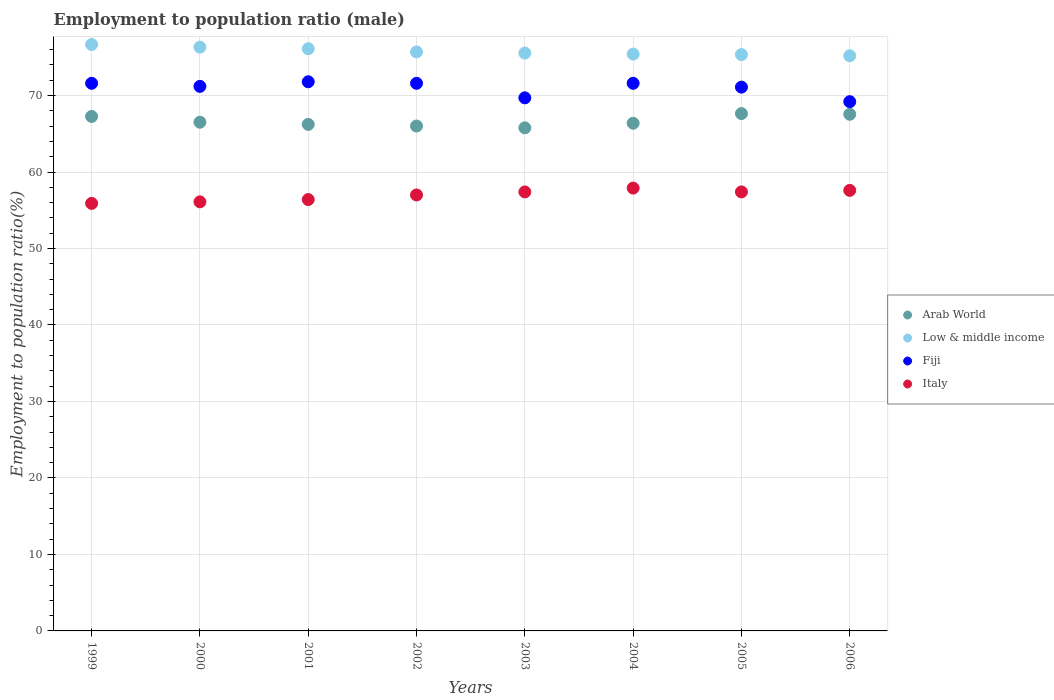How many different coloured dotlines are there?
Offer a very short reply. 4. What is the employment to population ratio in Italy in 2005?
Your answer should be very brief. 57.4. Across all years, what is the maximum employment to population ratio in Italy?
Your response must be concise. 57.9. Across all years, what is the minimum employment to population ratio in Italy?
Give a very brief answer. 55.9. What is the total employment to population ratio in Italy in the graph?
Offer a terse response. 455.7. What is the difference between the employment to population ratio in Fiji in 2001 and that in 2006?
Provide a short and direct response. 2.6. What is the difference between the employment to population ratio in Fiji in 2002 and the employment to population ratio in Low & middle income in 1999?
Provide a short and direct response. -5.07. What is the average employment to population ratio in Arab World per year?
Keep it short and to the point. 66.67. In the year 1999, what is the difference between the employment to population ratio in Fiji and employment to population ratio in Low & middle income?
Offer a very short reply. -5.07. What is the ratio of the employment to population ratio in Fiji in 2002 to that in 2003?
Your response must be concise. 1.03. Is the employment to population ratio in Arab World in 2002 less than that in 2006?
Keep it short and to the point. Yes. What is the difference between the highest and the second highest employment to population ratio in Arab World?
Offer a very short reply. 0.09. What is the difference between the highest and the lowest employment to population ratio in Fiji?
Your answer should be very brief. 2.6. Is it the case that in every year, the sum of the employment to population ratio in Low & middle income and employment to population ratio in Italy  is greater than the sum of employment to population ratio in Fiji and employment to population ratio in Arab World?
Offer a very short reply. No. Is it the case that in every year, the sum of the employment to population ratio in Arab World and employment to population ratio in Low & middle income  is greater than the employment to population ratio in Italy?
Make the answer very short. Yes. Is the employment to population ratio in Fiji strictly greater than the employment to population ratio in Italy over the years?
Give a very brief answer. Yes. Are the values on the major ticks of Y-axis written in scientific E-notation?
Offer a very short reply. No. Does the graph contain any zero values?
Give a very brief answer. No. Does the graph contain grids?
Ensure brevity in your answer.  Yes. Where does the legend appear in the graph?
Keep it short and to the point. Center right. How many legend labels are there?
Provide a short and direct response. 4. What is the title of the graph?
Give a very brief answer. Employment to population ratio (male). What is the label or title of the X-axis?
Make the answer very short. Years. What is the Employment to population ratio(%) of Arab World in 1999?
Offer a terse response. 67.26. What is the Employment to population ratio(%) of Low & middle income in 1999?
Provide a succinct answer. 76.67. What is the Employment to population ratio(%) in Fiji in 1999?
Make the answer very short. 71.6. What is the Employment to population ratio(%) of Italy in 1999?
Your answer should be very brief. 55.9. What is the Employment to population ratio(%) of Arab World in 2000?
Offer a terse response. 66.51. What is the Employment to population ratio(%) in Low & middle income in 2000?
Your answer should be compact. 76.33. What is the Employment to population ratio(%) in Fiji in 2000?
Ensure brevity in your answer.  71.2. What is the Employment to population ratio(%) of Italy in 2000?
Provide a short and direct response. 56.1. What is the Employment to population ratio(%) in Arab World in 2001?
Your response must be concise. 66.23. What is the Employment to population ratio(%) of Low & middle income in 2001?
Keep it short and to the point. 76.12. What is the Employment to population ratio(%) in Fiji in 2001?
Provide a succinct answer. 71.8. What is the Employment to population ratio(%) in Italy in 2001?
Make the answer very short. 56.4. What is the Employment to population ratio(%) of Arab World in 2002?
Make the answer very short. 66.02. What is the Employment to population ratio(%) in Low & middle income in 2002?
Offer a terse response. 75.7. What is the Employment to population ratio(%) of Fiji in 2002?
Offer a very short reply. 71.6. What is the Employment to population ratio(%) of Italy in 2002?
Your answer should be very brief. 57. What is the Employment to population ratio(%) of Arab World in 2003?
Ensure brevity in your answer.  65.78. What is the Employment to population ratio(%) in Low & middle income in 2003?
Offer a very short reply. 75.55. What is the Employment to population ratio(%) of Fiji in 2003?
Your answer should be very brief. 69.7. What is the Employment to population ratio(%) in Italy in 2003?
Provide a succinct answer. 57.4. What is the Employment to population ratio(%) of Arab World in 2004?
Ensure brevity in your answer.  66.38. What is the Employment to population ratio(%) of Low & middle income in 2004?
Keep it short and to the point. 75.41. What is the Employment to population ratio(%) in Fiji in 2004?
Provide a short and direct response. 71.6. What is the Employment to population ratio(%) in Italy in 2004?
Offer a very short reply. 57.9. What is the Employment to population ratio(%) in Arab World in 2005?
Your answer should be compact. 67.64. What is the Employment to population ratio(%) of Low & middle income in 2005?
Ensure brevity in your answer.  75.36. What is the Employment to population ratio(%) of Fiji in 2005?
Keep it short and to the point. 71.1. What is the Employment to population ratio(%) of Italy in 2005?
Provide a succinct answer. 57.4. What is the Employment to population ratio(%) of Arab World in 2006?
Ensure brevity in your answer.  67.55. What is the Employment to population ratio(%) in Low & middle income in 2006?
Your answer should be very brief. 75.2. What is the Employment to population ratio(%) of Fiji in 2006?
Your answer should be compact. 69.2. What is the Employment to population ratio(%) of Italy in 2006?
Your answer should be very brief. 57.6. Across all years, what is the maximum Employment to population ratio(%) of Arab World?
Offer a very short reply. 67.64. Across all years, what is the maximum Employment to population ratio(%) in Low & middle income?
Provide a succinct answer. 76.67. Across all years, what is the maximum Employment to population ratio(%) in Fiji?
Make the answer very short. 71.8. Across all years, what is the maximum Employment to population ratio(%) in Italy?
Your answer should be very brief. 57.9. Across all years, what is the minimum Employment to population ratio(%) of Arab World?
Make the answer very short. 65.78. Across all years, what is the minimum Employment to population ratio(%) of Low & middle income?
Provide a succinct answer. 75.2. Across all years, what is the minimum Employment to population ratio(%) of Fiji?
Make the answer very short. 69.2. Across all years, what is the minimum Employment to population ratio(%) in Italy?
Provide a succinct answer. 55.9. What is the total Employment to population ratio(%) in Arab World in the graph?
Ensure brevity in your answer.  533.37. What is the total Employment to population ratio(%) in Low & middle income in the graph?
Your answer should be compact. 606.34. What is the total Employment to population ratio(%) in Fiji in the graph?
Your answer should be very brief. 567.8. What is the total Employment to population ratio(%) of Italy in the graph?
Your response must be concise. 455.7. What is the difference between the Employment to population ratio(%) in Arab World in 1999 and that in 2000?
Make the answer very short. 0.75. What is the difference between the Employment to population ratio(%) of Low & middle income in 1999 and that in 2000?
Make the answer very short. 0.34. What is the difference between the Employment to population ratio(%) in Italy in 1999 and that in 2000?
Your answer should be compact. -0.2. What is the difference between the Employment to population ratio(%) in Arab World in 1999 and that in 2001?
Your answer should be very brief. 1.04. What is the difference between the Employment to population ratio(%) of Low & middle income in 1999 and that in 2001?
Keep it short and to the point. 0.55. What is the difference between the Employment to population ratio(%) of Italy in 1999 and that in 2001?
Make the answer very short. -0.5. What is the difference between the Employment to population ratio(%) in Arab World in 1999 and that in 2002?
Provide a short and direct response. 1.25. What is the difference between the Employment to population ratio(%) in Low & middle income in 1999 and that in 2002?
Provide a succinct answer. 0.97. What is the difference between the Employment to population ratio(%) of Arab World in 1999 and that in 2003?
Provide a short and direct response. 1.49. What is the difference between the Employment to population ratio(%) in Low & middle income in 1999 and that in 2003?
Make the answer very short. 1.12. What is the difference between the Employment to population ratio(%) of Italy in 1999 and that in 2003?
Offer a very short reply. -1.5. What is the difference between the Employment to population ratio(%) in Arab World in 1999 and that in 2004?
Offer a very short reply. 0.89. What is the difference between the Employment to population ratio(%) in Low & middle income in 1999 and that in 2004?
Offer a very short reply. 1.26. What is the difference between the Employment to population ratio(%) of Italy in 1999 and that in 2004?
Give a very brief answer. -2. What is the difference between the Employment to population ratio(%) of Arab World in 1999 and that in 2005?
Offer a very short reply. -0.37. What is the difference between the Employment to population ratio(%) of Low & middle income in 1999 and that in 2005?
Give a very brief answer. 1.31. What is the difference between the Employment to population ratio(%) in Fiji in 1999 and that in 2005?
Your answer should be compact. 0.5. What is the difference between the Employment to population ratio(%) of Italy in 1999 and that in 2005?
Provide a short and direct response. -1.5. What is the difference between the Employment to population ratio(%) of Arab World in 1999 and that in 2006?
Offer a very short reply. -0.29. What is the difference between the Employment to population ratio(%) in Low & middle income in 1999 and that in 2006?
Keep it short and to the point. 1.47. What is the difference between the Employment to population ratio(%) of Fiji in 1999 and that in 2006?
Provide a succinct answer. 2.4. What is the difference between the Employment to population ratio(%) of Italy in 1999 and that in 2006?
Ensure brevity in your answer.  -1.7. What is the difference between the Employment to population ratio(%) of Arab World in 2000 and that in 2001?
Offer a very short reply. 0.29. What is the difference between the Employment to population ratio(%) of Low & middle income in 2000 and that in 2001?
Provide a succinct answer. 0.21. What is the difference between the Employment to population ratio(%) in Fiji in 2000 and that in 2001?
Give a very brief answer. -0.6. What is the difference between the Employment to population ratio(%) of Italy in 2000 and that in 2001?
Provide a short and direct response. -0.3. What is the difference between the Employment to population ratio(%) in Arab World in 2000 and that in 2002?
Your response must be concise. 0.5. What is the difference between the Employment to population ratio(%) of Low & middle income in 2000 and that in 2002?
Offer a terse response. 0.63. What is the difference between the Employment to population ratio(%) of Fiji in 2000 and that in 2002?
Your answer should be compact. -0.4. What is the difference between the Employment to population ratio(%) of Italy in 2000 and that in 2002?
Provide a short and direct response. -0.9. What is the difference between the Employment to population ratio(%) in Arab World in 2000 and that in 2003?
Ensure brevity in your answer.  0.73. What is the difference between the Employment to population ratio(%) in Low & middle income in 2000 and that in 2003?
Ensure brevity in your answer.  0.78. What is the difference between the Employment to population ratio(%) in Italy in 2000 and that in 2003?
Provide a succinct answer. -1.3. What is the difference between the Employment to population ratio(%) of Arab World in 2000 and that in 2004?
Offer a terse response. 0.13. What is the difference between the Employment to population ratio(%) of Low & middle income in 2000 and that in 2004?
Provide a succinct answer. 0.91. What is the difference between the Employment to population ratio(%) of Arab World in 2000 and that in 2005?
Keep it short and to the point. -1.12. What is the difference between the Employment to population ratio(%) of Low & middle income in 2000 and that in 2005?
Ensure brevity in your answer.  0.97. What is the difference between the Employment to population ratio(%) of Fiji in 2000 and that in 2005?
Offer a very short reply. 0.1. What is the difference between the Employment to population ratio(%) of Italy in 2000 and that in 2005?
Keep it short and to the point. -1.3. What is the difference between the Employment to population ratio(%) of Arab World in 2000 and that in 2006?
Provide a succinct answer. -1.04. What is the difference between the Employment to population ratio(%) in Low & middle income in 2000 and that in 2006?
Offer a terse response. 1.12. What is the difference between the Employment to population ratio(%) of Fiji in 2000 and that in 2006?
Your answer should be very brief. 2. What is the difference between the Employment to population ratio(%) of Arab World in 2001 and that in 2002?
Provide a short and direct response. 0.21. What is the difference between the Employment to population ratio(%) of Low & middle income in 2001 and that in 2002?
Offer a terse response. 0.42. What is the difference between the Employment to population ratio(%) in Arab World in 2001 and that in 2003?
Your response must be concise. 0.45. What is the difference between the Employment to population ratio(%) of Low & middle income in 2001 and that in 2003?
Provide a succinct answer. 0.57. What is the difference between the Employment to population ratio(%) of Fiji in 2001 and that in 2003?
Your answer should be compact. 2.1. What is the difference between the Employment to population ratio(%) in Italy in 2001 and that in 2003?
Keep it short and to the point. -1. What is the difference between the Employment to population ratio(%) of Arab World in 2001 and that in 2004?
Ensure brevity in your answer.  -0.15. What is the difference between the Employment to population ratio(%) in Low & middle income in 2001 and that in 2004?
Provide a short and direct response. 0.71. What is the difference between the Employment to population ratio(%) in Fiji in 2001 and that in 2004?
Give a very brief answer. 0.2. What is the difference between the Employment to population ratio(%) of Arab World in 2001 and that in 2005?
Ensure brevity in your answer.  -1.41. What is the difference between the Employment to population ratio(%) in Low & middle income in 2001 and that in 2005?
Give a very brief answer. 0.76. What is the difference between the Employment to population ratio(%) in Fiji in 2001 and that in 2005?
Offer a terse response. 0.7. What is the difference between the Employment to population ratio(%) in Arab World in 2001 and that in 2006?
Your answer should be compact. -1.32. What is the difference between the Employment to population ratio(%) of Low & middle income in 2001 and that in 2006?
Provide a succinct answer. 0.92. What is the difference between the Employment to population ratio(%) of Arab World in 2002 and that in 2003?
Give a very brief answer. 0.24. What is the difference between the Employment to population ratio(%) of Low & middle income in 2002 and that in 2003?
Offer a terse response. 0.15. What is the difference between the Employment to population ratio(%) of Fiji in 2002 and that in 2003?
Ensure brevity in your answer.  1.9. What is the difference between the Employment to population ratio(%) in Arab World in 2002 and that in 2004?
Provide a succinct answer. -0.36. What is the difference between the Employment to population ratio(%) of Low & middle income in 2002 and that in 2004?
Give a very brief answer. 0.29. What is the difference between the Employment to population ratio(%) in Fiji in 2002 and that in 2004?
Ensure brevity in your answer.  0. What is the difference between the Employment to population ratio(%) in Arab World in 2002 and that in 2005?
Provide a succinct answer. -1.62. What is the difference between the Employment to population ratio(%) of Low & middle income in 2002 and that in 2005?
Provide a succinct answer. 0.34. What is the difference between the Employment to population ratio(%) in Fiji in 2002 and that in 2005?
Keep it short and to the point. 0.5. What is the difference between the Employment to population ratio(%) in Italy in 2002 and that in 2005?
Offer a terse response. -0.4. What is the difference between the Employment to population ratio(%) of Arab World in 2002 and that in 2006?
Ensure brevity in your answer.  -1.54. What is the difference between the Employment to population ratio(%) in Low & middle income in 2002 and that in 2006?
Your response must be concise. 0.5. What is the difference between the Employment to population ratio(%) in Arab World in 2003 and that in 2004?
Provide a short and direct response. -0.6. What is the difference between the Employment to population ratio(%) of Low & middle income in 2003 and that in 2004?
Ensure brevity in your answer.  0.13. What is the difference between the Employment to population ratio(%) in Fiji in 2003 and that in 2004?
Provide a short and direct response. -1.9. What is the difference between the Employment to population ratio(%) of Arab World in 2003 and that in 2005?
Offer a very short reply. -1.86. What is the difference between the Employment to population ratio(%) in Low & middle income in 2003 and that in 2005?
Your answer should be very brief. 0.19. What is the difference between the Employment to population ratio(%) of Fiji in 2003 and that in 2005?
Your response must be concise. -1.4. What is the difference between the Employment to population ratio(%) in Italy in 2003 and that in 2005?
Make the answer very short. 0. What is the difference between the Employment to population ratio(%) of Arab World in 2003 and that in 2006?
Offer a terse response. -1.77. What is the difference between the Employment to population ratio(%) in Low & middle income in 2003 and that in 2006?
Your answer should be compact. 0.35. What is the difference between the Employment to population ratio(%) in Arab World in 2004 and that in 2005?
Offer a terse response. -1.26. What is the difference between the Employment to population ratio(%) of Low & middle income in 2004 and that in 2005?
Ensure brevity in your answer.  0.06. What is the difference between the Employment to population ratio(%) of Arab World in 2004 and that in 2006?
Offer a terse response. -1.17. What is the difference between the Employment to population ratio(%) of Low & middle income in 2004 and that in 2006?
Ensure brevity in your answer.  0.21. What is the difference between the Employment to population ratio(%) of Italy in 2004 and that in 2006?
Keep it short and to the point. 0.3. What is the difference between the Employment to population ratio(%) of Arab World in 2005 and that in 2006?
Provide a succinct answer. 0.09. What is the difference between the Employment to population ratio(%) in Low & middle income in 2005 and that in 2006?
Your answer should be compact. 0.15. What is the difference between the Employment to population ratio(%) of Italy in 2005 and that in 2006?
Make the answer very short. -0.2. What is the difference between the Employment to population ratio(%) in Arab World in 1999 and the Employment to population ratio(%) in Low & middle income in 2000?
Give a very brief answer. -9.06. What is the difference between the Employment to population ratio(%) in Arab World in 1999 and the Employment to population ratio(%) in Fiji in 2000?
Your answer should be very brief. -3.94. What is the difference between the Employment to population ratio(%) in Arab World in 1999 and the Employment to population ratio(%) in Italy in 2000?
Make the answer very short. 11.16. What is the difference between the Employment to population ratio(%) of Low & middle income in 1999 and the Employment to population ratio(%) of Fiji in 2000?
Keep it short and to the point. 5.47. What is the difference between the Employment to population ratio(%) in Low & middle income in 1999 and the Employment to population ratio(%) in Italy in 2000?
Provide a short and direct response. 20.57. What is the difference between the Employment to population ratio(%) of Fiji in 1999 and the Employment to population ratio(%) of Italy in 2000?
Your answer should be very brief. 15.5. What is the difference between the Employment to population ratio(%) of Arab World in 1999 and the Employment to population ratio(%) of Low & middle income in 2001?
Your answer should be very brief. -8.86. What is the difference between the Employment to population ratio(%) of Arab World in 1999 and the Employment to population ratio(%) of Fiji in 2001?
Keep it short and to the point. -4.54. What is the difference between the Employment to population ratio(%) of Arab World in 1999 and the Employment to population ratio(%) of Italy in 2001?
Offer a terse response. 10.86. What is the difference between the Employment to population ratio(%) of Low & middle income in 1999 and the Employment to population ratio(%) of Fiji in 2001?
Your answer should be compact. 4.87. What is the difference between the Employment to population ratio(%) in Low & middle income in 1999 and the Employment to population ratio(%) in Italy in 2001?
Your answer should be compact. 20.27. What is the difference between the Employment to population ratio(%) of Fiji in 1999 and the Employment to population ratio(%) of Italy in 2001?
Your response must be concise. 15.2. What is the difference between the Employment to population ratio(%) of Arab World in 1999 and the Employment to population ratio(%) of Low & middle income in 2002?
Your answer should be compact. -8.44. What is the difference between the Employment to population ratio(%) of Arab World in 1999 and the Employment to population ratio(%) of Fiji in 2002?
Offer a very short reply. -4.34. What is the difference between the Employment to population ratio(%) in Arab World in 1999 and the Employment to population ratio(%) in Italy in 2002?
Give a very brief answer. 10.26. What is the difference between the Employment to population ratio(%) in Low & middle income in 1999 and the Employment to population ratio(%) in Fiji in 2002?
Your response must be concise. 5.07. What is the difference between the Employment to population ratio(%) in Low & middle income in 1999 and the Employment to population ratio(%) in Italy in 2002?
Your response must be concise. 19.67. What is the difference between the Employment to population ratio(%) in Fiji in 1999 and the Employment to population ratio(%) in Italy in 2002?
Your answer should be compact. 14.6. What is the difference between the Employment to population ratio(%) of Arab World in 1999 and the Employment to population ratio(%) of Low & middle income in 2003?
Ensure brevity in your answer.  -8.28. What is the difference between the Employment to population ratio(%) in Arab World in 1999 and the Employment to population ratio(%) in Fiji in 2003?
Ensure brevity in your answer.  -2.44. What is the difference between the Employment to population ratio(%) of Arab World in 1999 and the Employment to population ratio(%) of Italy in 2003?
Keep it short and to the point. 9.86. What is the difference between the Employment to population ratio(%) in Low & middle income in 1999 and the Employment to population ratio(%) in Fiji in 2003?
Your answer should be compact. 6.97. What is the difference between the Employment to population ratio(%) of Low & middle income in 1999 and the Employment to population ratio(%) of Italy in 2003?
Ensure brevity in your answer.  19.27. What is the difference between the Employment to population ratio(%) of Fiji in 1999 and the Employment to population ratio(%) of Italy in 2003?
Your answer should be compact. 14.2. What is the difference between the Employment to population ratio(%) of Arab World in 1999 and the Employment to population ratio(%) of Low & middle income in 2004?
Keep it short and to the point. -8.15. What is the difference between the Employment to population ratio(%) of Arab World in 1999 and the Employment to population ratio(%) of Fiji in 2004?
Offer a terse response. -4.34. What is the difference between the Employment to population ratio(%) in Arab World in 1999 and the Employment to population ratio(%) in Italy in 2004?
Offer a terse response. 9.36. What is the difference between the Employment to population ratio(%) in Low & middle income in 1999 and the Employment to population ratio(%) in Fiji in 2004?
Provide a short and direct response. 5.07. What is the difference between the Employment to population ratio(%) of Low & middle income in 1999 and the Employment to population ratio(%) of Italy in 2004?
Make the answer very short. 18.77. What is the difference between the Employment to population ratio(%) of Fiji in 1999 and the Employment to population ratio(%) of Italy in 2004?
Keep it short and to the point. 13.7. What is the difference between the Employment to population ratio(%) in Arab World in 1999 and the Employment to population ratio(%) in Low & middle income in 2005?
Give a very brief answer. -8.09. What is the difference between the Employment to population ratio(%) of Arab World in 1999 and the Employment to population ratio(%) of Fiji in 2005?
Make the answer very short. -3.84. What is the difference between the Employment to population ratio(%) of Arab World in 1999 and the Employment to population ratio(%) of Italy in 2005?
Provide a short and direct response. 9.86. What is the difference between the Employment to population ratio(%) in Low & middle income in 1999 and the Employment to population ratio(%) in Fiji in 2005?
Provide a succinct answer. 5.57. What is the difference between the Employment to population ratio(%) in Low & middle income in 1999 and the Employment to population ratio(%) in Italy in 2005?
Provide a succinct answer. 19.27. What is the difference between the Employment to population ratio(%) of Arab World in 1999 and the Employment to population ratio(%) of Low & middle income in 2006?
Offer a very short reply. -7.94. What is the difference between the Employment to population ratio(%) in Arab World in 1999 and the Employment to population ratio(%) in Fiji in 2006?
Make the answer very short. -1.94. What is the difference between the Employment to population ratio(%) in Arab World in 1999 and the Employment to population ratio(%) in Italy in 2006?
Provide a short and direct response. 9.66. What is the difference between the Employment to population ratio(%) of Low & middle income in 1999 and the Employment to population ratio(%) of Fiji in 2006?
Provide a succinct answer. 7.47. What is the difference between the Employment to population ratio(%) of Low & middle income in 1999 and the Employment to population ratio(%) of Italy in 2006?
Ensure brevity in your answer.  19.07. What is the difference between the Employment to population ratio(%) of Arab World in 2000 and the Employment to population ratio(%) of Low & middle income in 2001?
Your answer should be compact. -9.61. What is the difference between the Employment to population ratio(%) of Arab World in 2000 and the Employment to population ratio(%) of Fiji in 2001?
Your answer should be compact. -5.29. What is the difference between the Employment to population ratio(%) in Arab World in 2000 and the Employment to population ratio(%) in Italy in 2001?
Your answer should be compact. 10.11. What is the difference between the Employment to population ratio(%) of Low & middle income in 2000 and the Employment to population ratio(%) of Fiji in 2001?
Provide a short and direct response. 4.53. What is the difference between the Employment to population ratio(%) in Low & middle income in 2000 and the Employment to population ratio(%) in Italy in 2001?
Ensure brevity in your answer.  19.93. What is the difference between the Employment to population ratio(%) in Arab World in 2000 and the Employment to population ratio(%) in Low & middle income in 2002?
Keep it short and to the point. -9.19. What is the difference between the Employment to population ratio(%) of Arab World in 2000 and the Employment to population ratio(%) of Fiji in 2002?
Provide a succinct answer. -5.09. What is the difference between the Employment to population ratio(%) of Arab World in 2000 and the Employment to population ratio(%) of Italy in 2002?
Keep it short and to the point. 9.51. What is the difference between the Employment to population ratio(%) of Low & middle income in 2000 and the Employment to population ratio(%) of Fiji in 2002?
Provide a succinct answer. 4.73. What is the difference between the Employment to population ratio(%) in Low & middle income in 2000 and the Employment to population ratio(%) in Italy in 2002?
Offer a very short reply. 19.33. What is the difference between the Employment to population ratio(%) of Fiji in 2000 and the Employment to population ratio(%) of Italy in 2002?
Provide a succinct answer. 14.2. What is the difference between the Employment to population ratio(%) in Arab World in 2000 and the Employment to population ratio(%) in Low & middle income in 2003?
Your answer should be very brief. -9.03. What is the difference between the Employment to population ratio(%) in Arab World in 2000 and the Employment to population ratio(%) in Fiji in 2003?
Keep it short and to the point. -3.19. What is the difference between the Employment to population ratio(%) of Arab World in 2000 and the Employment to population ratio(%) of Italy in 2003?
Your answer should be compact. 9.11. What is the difference between the Employment to population ratio(%) in Low & middle income in 2000 and the Employment to population ratio(%) in Fiji in 2003?
Keep it short and to the point. 6.63. What is the difference between the Employment to population ratio(%) in Low & middle income in 2000 and the Employment to population ratio(%) in Italy in 2003?
Keep it short and to the point. 18.93. What is the difference between the Employment to population ratio(%) in Fiji in 2000 and the Employment to population ratio(%) in Italy in 2003?
Provide a short and direct response. 13.8. What is the difference between the Employment to population ratio(%) in Arab World in 2000 and the Employment to population ratio(%) in Low & middle income in 2004?
Offer a terse response. -8.9. What is the difference between the Employment to population ratio(%) of Arab World in 2000 and the Employment to population ratio(%) of Fiji in 2004?
Provide a short and direct response. -5.09. What is the difference between the Employment to population ratio(%) of Arab World in 2000 and the Employment to population ratio(%) of Italy in 2004?
Ensure brevity in your answer.  8.61. What is the difference between the Employment to population ratio(%) in Low & middle income in 2000 and the Employment to population ratio(%) in Fiji in 2004?
Your answer should be very brief. 4.73. What is the difference between the Employment to population ratio(%) in Low & middle income in 2000 and the Employment to population ratio(%) in Italy in 2004?
Provide a succinct answer. 18.43. What is the difference between the Employment to population ratio(%) in Fiji in 2000 and the Employment to population ratio(%) in Italy in 2004?
Provide a short and direct response. 13.3. What is the difference between the Employment to population ratio(%) in Arab World in 2000 and the Employment to population ratio(%) in Low & middle income in 2005?
Keep it short and to the point. -8.84. What is the difference between the Employment to population ratio(%) of Arab World in 2000 and the Employment to population ratio(%) of Fiji in 2005?
Give a very brief answer. -4.59. What is the difference between the Employment to population ratio(%) in Arab World in 2000 and the Employment to population ratio(%) in Italy in 2005?
Your answer should be very brief. 9.11. What is the difference between the Employment to population ratio(%) of Low & middle income in 2000 and the Employment to population ratio(%) of Fiji in 2005?
Ensure brevity in your answer.  5.23. What is the difference between the Employment to population ratio(%) in Low & middle income in 2000 and the Employment to population ratio(%) in Italy in 2005?
Give a very brief answer. 18.93. What is the difference between the Employment to population ratio(%) in Arab World in 2000 and the Employment to population ratio(%) in Low & middle income in 2006?
Provide a succinct answer. -8.69. What is the difference between the Employment to population ratio(%) of Arab World in 2000 and the Employment to population ratio(%) of Fiji in 2006?
Ensure brevity in your answer.  -2.69. What is the difference between the Employment to population ratio(%) of Arab World in 2000 and the Employment to population ratio(%) of Italy in 2006?
Ensure brevity in your answer.  8.91. What is the difference between the Employment to population ratio(%) of Low & middle income in 2000 and the Employment to population ratio(%) of Fiji in 2006?
Your response must be concise. 7.13. What is the difference between the Employment to population ratio(%) of Low & middle income in 2000 and the Employment to population ratio(%) of Italy in 2006?
Make the answer very short. 18.73. What is the difference between the Employment to population ratio(%) of Fiji in 2000 and the Employment to population ratio(%) of Italy in 2006?
Provide a succinct answer. 13.6. What is the difference between the Employment to population ratio(%) in Arab World in 2001 and the Employment to population ratio(%) in Low & middle income in 2002?
Your answer should be very brief. -9.47. What is the difference between the Employment to population ratio(%) in Arab World in 2001 and the Employment to population ratio(%) in Fiji in 2002?
Make the answer very short. -5.37. What is the difference between the Employment to population ratio(%) of Arab World in 2001 and the Employment to population ratio(%) of Italy in 2002?
Provide a succinct answer. 9.23. What is the difference between the Employment to population ratio(%) in Low & middle income in 2001 and the Employment to population ratio(%) in Fiji in 2002?
Make the answer very short. 4.52. What is the difference between the Employment to population ratio(%) in Low & middle income in 2001 and the Employment to population ratio(%) in Italy in 2002?
Your answer should be compact. 19.12. What is the difference between the Employment to population ratio(%) of Fiji in 2001 and the Employment to population ratio(%) of Italy in 2002?
Make the answer very short. 14.8. What is the difference between the Employment to population ratio(%) of Arab World in 2001 and the Employment to population ratio(%) of Low & middle income in 2003?
Offer a terse response. -9.32. What is the difference between the Employment to population ratio(%) in Arab World in 2001 and the Employment to population ratio(%) in Fiji in 2003?
Ensure brevity in your answer.  -3.47. What is the difference between the Employment to population ratio(%) in Arab World in 2001 and the Employment to population ratio(%) in Italy in 2003?
Your response must be concise. 8.83. What is the difference between the Employment to population ratio(%) in Low & middle income in 2001 and the Employment to population ratio(%) in Fiji in 2003?
Ensure brevity in your answer.  6.42. What is the difference between the Employment to population ratio(%) in Low & middle income in 2001 and the Employment to population ratio(%) in Italy in 2003?
Your response must be concise. 18.72. What is the difference between the Employment to population ratio(%) of Fiji in 2001 and the Employment to population ratio(%) of Italy in 2003?
Offer a very short reply. 14.4. What is the difference between the Employment to population ratio(%) of Arab World in 2001 and the Employment to population ratio(%) of Low & middle income in 2004?
Give a very brief answer. -9.19. What is the difference between the Employment to population ratio(%) of Arab World in 2001 and the Employment to population ratio(%) of Fiji in 2004?
Keep it short and to the point. -5.37. What is the difference between the Employment to population ratio(%) of Arab World in 2001 and the Employment to population ratio(%) of Italy in 2004?
Provide a succinct answer. 8.33. What is the difference between the Employment to population ratio(%) of Low & middle income in 2001 and the Employment to population ratio(%) of Fiji in 2004?
Keep it short and to the point. 4.52. What is the difference between the Employment to population ratio(%) in Low & middle income in 2001 and the Employment to population ratio(%) in Italy in 2004?
Your answer should be very brief. 18.22. What is the difference between the Employment to population ratio(%) in Arab World in 2001 and the Employment to population ratio(%) in Low & middle income in 2005?
Your answer should be very brief. -9.13. What is the difference between the Employment to population ratio(%) of Arab World in 2001 and the Employment to population ratio(%) of Fiji in 2005?
Your answer should be compact. -4.87. What is the difference between the Employment to population ratio(%) of Arab World in 2001 and the Employment to population ratio(%) of Italy in 2005?
Keep it short and to the point. 8.83. What is the difference between the Employment to population ratio(%) in Low & middle income in 2001 and the Employment to population ratio(%) in Fiji in 2005?
Your answer should be compact. 5.02. What is the difference between the Employment to population ratio(%) of Low & middle income in 2001 and the Employment to population ratio(%) of Italy in 2005?
Your answer should be compact. 18.72. What is the difference between the Employment to population ratio(%) of Fiji in 2001 and the Employment to population ratio(%) of Italy in 2005?
Your answer should be very brief. 14.4. What is the difference between the Employment to population ratio(%) of Arab World in 2001 and the Employment to population ratio(%) of Low & middle income in 2006?
Give a very brief answer. -8.97. What is the difference between the Employment to population ratio(%) of Arab World in 2001 and the Employment to population ratio(%) of Fiji in 2006?
Your answer should be very brief. -2.97. What is the difference between the Employment to population ratio(%) in Arab World in 2001 and the Employment to population ratio(%) in Italy in 2006?
Provide a succinct answer. 8.63. What is the difference between the Employment to population ratio(%) of Low & middle income in 2001 and the Employment to population ratio(%) of Fiji in 2006?
Your response must be concise. 6.92. What is the difference between the Employment to population ratio(%) in Low & middle income in 2001 and the Employment to population ratio(%) in Italy in 2006?
Provide a succinct answer. 18.52. What is the difference between the Employment to population ratio(%) in Fiji in 2001 and the Employment to population ratio(%) in Italy in 2006?
Provide a short and direct response. 14.2. What is the difference between the Employment to population ratio(%) in Arab World in 2002 and the Employment to population ratio(%) in Low & middle income in 2003?
Your response must be concise. -9.53. What is the difference between the Employment to population ratio(%) of Arab World in 2002 and the Employment to population ratio(%) of Fiji in 2003?
Offer a very short reply. -3.69. What is the difference between the Employment to population ratio(%) in Arab World in 2002 and the Employment to population ratio(%) in Italy in 2003?
Your response must be concise. 8.62. What is the difference between the Employment to population ratio(%) of Low & middle income in 2002 and the Employment to population ratio(%) of Fiji in 2003?
Make the answer very short. 6. What is the difference between the Employment to population ratio(%) of Low & middle income in 2002 and the Employment to population ratio(%) of Italy in 2003?
Your answer should be very brief. 18.3. What is the difference between the Employment to population ratio(%) in Arab World in 2002 and the Employment to population ratio(%) in Low & middle income in 2004?
Offer a terse response. -9.4. What is the difference between the Employment to population ratio(%) of Arab World in 2002 and the Employment to population ratio(%) of Fiji in 2004?
Make the answer very short. -5.58. What is the difference between the Employment to population ratio(%) in Arab World in 2002 and the Employment to population ratio(%) in Italy in 2004?
Offer a terse response. 8.12. What is the difference between the Employment to population ratio(%) of Low & middle income in 2002 and the Employment to population ratio(%) of Fiji in 2004?
Offer a terse response. 4.1. What is the difference between the Employment to population ratio(%) in Low & middle income in 2002 and the Employment to population ratio(%) in Italy in 2004?
Offer a very short reply. 17.8. What is the difference between the Employment to population ratio(%) in Fiji in 2002 and the Employment to population ratio(%) in Italy in 2004?
Your answer should be very brief. 13.7. What is the difference between the Employment to population ratio(%) of Arab World in 2002 and the Employment to population ratio(%) of Low & middle income in 2005?
Ensure brevity in your answer.  -9.34. What is the difference between the Employment to population ratio(%) in Arab World in 2002 and the Employment to population ratio(%) in Fiji in 2005?
Ensure brevity in your answer.  -5.08. What is the difference between the Employment to population ratio(%) in Arab World in 2002 and the Employment to population ratio(%) in Italy in 2005?
Offer a terse response. 8.62. What is the difference between the Employment to population ratio(%) of Low & middle income in 2002 and the Employment to population ratio(%) of Fiji in 2005?
Give a very brief answer. 4.6. What is the difference between the Employment to population ratio(%) in Low & middle income in 2002 and the Employment to population ratio(%) in Italy in 2005?
Ensure brevity in your answer.  18.3. What is the difference between the Employment to population ratio(%) of Arab World in 2002 and the Employment to population ratio(%) of Low & middle income in 2006?
Offer a very short reply. -9.19. What is the difference between the Employment to population ratio(%) of Arab World in 2002 and the Employment to population ratio(%) of Fiji in 2006?
Your answer should be compact. -3.19. What is the difference between the Employment to population ratio(%) in Arab World in 2002 and the Employment to population ratio(%) in Italy in 2006?
Offer a very short reply. 8.41. What is the difference between the Employment to population ratio(%) in Low & middle income in 2002 and the Employment to population ratio(%) in Fiji in 2006?
Your response must be concise. 6.5. What is the difference between the Employment to population ratio(%) of Low & middle income in 2002 and the Employment to population ratio(%) of Italy in 2006?
Offer a very short reply. 18.1. What is the difference between the Employment to population ratio(%) in Fiji in 2002 and the Employment to population ratio(%) in Italy in 2006?
Make the answer very short. 14. What is the difference between the Employment to population ratio(%) in Arab World in 2003 and the Employment to population ratio(%) in Low & middle income in 2004?
Keep it short and to the point. -9.63. What is the difference between the Employment to population ratio(%) of Arab World in 2003 and the Employment to population ratio(%) of Fiji in 2004?
Your response must be concise. -5.82. What is the difference between the Employment to population ratio(%) in Arab World in 2003 and the Employment to population ratio(%) in Italy in 2004?
Keep it short and to the point. 7.88. What is the difference between the Employment to population ratio(%) in Low & middle income in 2003 and the Employment to population ratio(%) in Fiji in 2004?
Provide a short and direct response. 3.95. What is the difference between the Employment to population ratio(%) in Low & middle income in 2003 and the Employment to population ratio(%) in Italy in 2004?
Keep it short and to the point. 17.65. What is the difference between the Employment to population ratio(%) in Fiji in 2003 and the Employment to population ratio(%) in Italy in 2004?
Offer a terse response. 11.8. What is the difference between the Employment to population ratio(%) in Arab World in 2003 and the Employment to population ratio(%) in Low & middle income in 2005?
Your response must be concise. -9.58. What is the difference between the Employment to population ratio(%) of Arab World in 2003 and the Employment to population ratio(%) of Fiji in 2005?
Give a very brief answer. -5.32. What is the difference between the Employment to population ratio(%) in Arab World in 2003 and the Employment to population ratio(%) in Italy in 2005?
Provide a short and direct response. 8.38. What is the difference between the Employment to population ratio(%) of Low & middle income in 2003 and the Employment to population ratio(%) of Fiji in 2005?
Provide a short and direct response. 4.45. What is the difference between the Employment to population ratio(%) of Low & middle income in 2003 and the Employment to population ratio(%) of Italy in 2005?
Offer a terse response. 18.15. What is the difference between the Employment to population ratio(%) of Fiji in 2003 and the Employment to population ratio(%) of Italy in 2005?
Keep it short and to the point. 12.3. What is the difference between the Employment to population ratio(%) of Arab World in 2003 and the Employment to population ratio(%) of Low & middle income in 2006?
Provide a succinct answer. -9.42. What is the difference between the Employment to population ratio(%) of Arab World in 2003 and the Employment to population ratio(%) of Fiji in 2006?
Your answer should be very brief. -3.42. What is the difference between the Employment to population ratio(%) of Arab World in 2003 and the Employment to population ratio(%) of Italy in 2006?
Give a very brief answer. 8.18. What is the difference between the Employment to population ratio(%) in Low & middle income in 2003 and the Employment to population ratio(%) in Fiji in 2006?
Keep it short and to the point. 6.35. What is the difference between the Employment to population ratio(%) in Low & middle income in 2003 and the Employment to population ratio(%) in Italy in 2006?
Keep it short and to the point. 17.95. What is the difference between the Employment to population ratio(%) of Fiji in 2003 and the Employment to population ratio(%) of Italy in 2006?
Give a very brief answer. 12.1. What is the difference between the Employment to population ratio(%) in Arab World in 2004 and the Employment to population ratio(%) in Low & middle income in 2005?
Your answer should be compact. -8.98. What is the difference between the Employment to population ratio(%) in Arab World in 2004 and the Employment to population ratio(%) in Fiji in 2005?
Give a very brief answer. -4.72. What is the difference between the Employment to population ratio(%) in Arab World in 2004 and the Employment to population ratio(%) in Italy in 2005?
Offer a terse response. 8.98. What is the difference between the Employment to population ratio(%) of Low & middle income in 2004 and the Employment to population ratio(%) of Fiji in 2005?
Ensure brevity in your answer.  4.32. What is the difference between the Employment to population ratio(%) of Low & middle income in 2004 and the Employment to population ratio(%) of Italy in 2005?
Your answer should be compact. 18.02. What is the difference between the Employment to population ratio(%) in Arab World in 2004 and the Employment to population ratio(%) in Low & middle income in 2006?
Give a very brief answer. -8.82. What is the difference between the Employment to population ratio(%) of Arab World in 2004 and the Employment to population ratio(%) of Fiji in 2006?
Give a very brief answer. -2.82. What is the difference between the Employment to population ratio(%) of Arab World in 2004 and the Employment to population ratio(%) of Italy in 2006?
Give a very brief answer. 8.78. What is the difference between the Employment to population ratio(%) in Low & middle income in 2004 and the Employment to population ratio(%) in Fiji in 2006?
Offer a very short reply. 6.21. What is the difference between the Employment to population ratio(%) in Low & middle income in 2004 and the Employment to population ratio(%) in Italy in 2006?
Give a very brief answer. 17.82. What is the difference between the Employment to population ratio(%) in Arab World in 2005 and the Employment to population ratio(%) in Low & middle income in 2006?
Your answer should be very brief. -7.56. What is the difference between the Employment to population ratio(%) of Arab World in 2005 and the Employment to population ratio(%) of Fiji in 2006?
Your answer should be very brief. -1.56. What is the difference between the Employment to population ratio(%) of Arab World in 2005 and the Employment to population ratio(%) of Italy in 2006?
Offer a terse response. 10.04. What is the difference between the Employment to population ratio(%) of Low & middle income in 2005 and the Employment to population ratio(%) of Fiji in 2006?
Provide a short and direct response. 6.16. What is the difference between the Employment to population ratio(%) in Low & middle income in 2005 and the Employment to population ratio(%) in Italy in 2006?
Offer a very short reply. 17.76. What is the average Employment to population ratio(%) of Arab World per year?
Keep it short and to the point. 66.67. What is the average Employment to population ratio(%) of Low & middle income per year?
Offer a terse response. 75.79. What is the average Employment to population ratio(%) of Fiji per year?
Your answer should be very brief. 70.97. What is the average Employment to population ratio(%) in Italy per year?
Give a very brief answer. 56.96. In the year 1999, what is the difference between the Employment to population ratio(%) of Arab World and Employment to population ratio(%) of Low & middle income?
Provide a succinct answer. -9.41. In the year 1999, what is the difference between the Employment to population ratio(%) in Arab World and Employment to population ratio(%) in Fiji?
Provide a succinct answer. -4.34. In the year 1999, what is the difference between the Employment to population ratio(%) in Arab World and Employment to population ratio(%) in Italy?
Your answer should be compact. 11.36. In the year 1999, what is the difference between the Employment to population ratio(%) of Low & middle income and Employment to population ratio(%) of Fiji?
Give a very brief answer. 5.07. In the year 1999, what is the difference between the Employment to population ratio(%) in Low & middle income and Employment to population ratio(%) in Italy?
Your response must be concise. 20.77. In the year 2000, what is the difference between the Employment to population ratio(%) of Arab World and Employment to population ratio(%) of Low & middle income?
Your answer should be very brief. -9.81. In the year 2000, what is the difference between the Employment to population ratio(%) in Arab World and Employment to population ratio(%) in Fiji?
Your answer should be compact. -4.69. In the year 2000, what is the difference between the Employment to population ratio(%) in Arab World and Employment to population ratio(%) in Italy?
Offer a very short reply. 10.41. In the year 2000, what is the difference between the Employment to population ratio(%) in Low & middle income and Employment to population ratio(%) in Fiji?
Your answer should be very brief. 5.13. In the year 2000, what is the difference between the Employment to population ratio(%) of Low & middle income and Employment to population ratio(%) of Italy?
Offer a very short reply. 20.23. In the year 2000, what is the difference between the Employment to population ratio(%) in Fiji and Employment to population ratio(%) in Italy?
Your response must be concise. 15.1. In the year 2001, what is the difference between the Employment to population ratio(%) in Arab World and Employment to population ratio(%) in Low & middle income?
Your answer should be very brief. -9.89. In the year 2001, what is the difference between the Employment to population ratio(%) in Arab World and Employment to population ratio(%) in Fiji?
Your answer should be very brief. -5.57. In the year 2001, what is the difference between the Employment to population ratio(%) in Arab World and Employment to population ratio(%) in Italy?
Ensure brevity in your answer.  9.83. In the year 2001, what is the difference between the Employment to population ratio(%) of Low & middle income and Employment to population ratio(%) of Fiji?
Make the answer very short. 4.32. In the year 2001, what is the difference between the Employment to population ratio(%) in Low & middle income and Employment to population ratio(%) in Italy?
Your answer should be compact. 19.72. In the year 2002, what is the difference between the Employment to population ratio(%) in Arab World and Employment to population ratio(%) in Low & middle income?
Offer a very short reply. -9.69. In the year 2002, what is the difference between the Employment to population ratio(%) in Arab World and Employment to population ratio(%) in Fiji?
Provide a succinct answer. -5.58. In the year 2002, what is the difference between the Employment to population ratio(%) of Arab World and Employment to population ratio(%) of Italy?
Give a very brief answer. 9.02. In the year 2002, what is the difference between the Employment to population ratio(%) of Low & middle income and Employment to population ratio(%) of Fiji?
Offer a terse response. 4.1. In the year 2002, what is the difference between the Employment to population ratio(%) in Low & middle income and Employment to population ratio(%) in Italy?
Your response must be concise. 18.7. In the year 2003, what is the difference between the Employment to population ratio(%) in Arab World and Employment to population ratio(%) in Low & middle income?
Make the answer very short. -9.77. In the year 2003, what is the difference between the Employment to population ratio(%) in Arab World and Employment to population ratio(%) in Fiji?
Your response must be concise. -3.92. In the year 2003, what is the difference between the Employment to population ratio(%) of Arab World and Employment to population ratio(%) of Italy?
Give a very brief answer. 8.38. In the year 2003, what is the difference between the Employment to population ratio(%) of Low & middle income and Employment to population ratio(%) of Fiji?
Ensure brevity in your answer.  5.85. In the year 2003, what is the difference between the Employment to population ratio(%) of Low & middle income and Employment to population ratio(%) of Italy?
Your answer should be compact. 18.15. In the year 2003, what is the difference between the Employment to population ratio(%) in Fiji and Employment to population ratio(%) in Italy?
Keep it short and to the point. 12.3. In the year 2004, what is the difference between the Employment to population ratio(%) of Arab World and Employment to population ratio(%) of Low & middle income?
Your answer should be very brief. -9.04. In the year 2004, what is the difference between the Employment to population ratio(%) of Arab World and Employment to population ratio(%) of Fiji?
Make the answer very short. -5.22. In the year 2004, what is the difference between the Employment to population ratio(%) of Arab World and Employment to population ratio(%) of Italy?
Provide a succinct answer. 8.48. In the year 2004, what is the difference between the Employment to population ratio(%) of Low & middle income and Employment to population ratio(%) of Fiji?
Ensure brevity in your answer.  3.81. In the year 2004, what is the difference between the Employment to population ratio(%) in Low & middle income and Employment to population ratio(%) in Italy?
Give a very brief answer. 17.52. In the year 2005, what is the difference between the Employment to population ratio(%) in Arab World and Employment to population ratio(%) in Low & middle income?
Provide a succinct answer. -7.72. In the year 2005, what is the difference between the Employment to population ratio(%) in Arab World and Employment to population ratio(%) in Fiji?
Your answer should be very brief. -3.46. In the year 2005, what is the difference between the Employment to population ratio(%) in Arab World and Employment to population ratio(%) in Italy?
Offer a terse response. 10.24. In the year 2005, what is the difference between the Employment to population ratio(%) of Low & middle income and Employment to population ratio(%) of Fiji?
Your answer should be compact. 4.26. In the year 2005, what is the difference between the Employment to population ratio(%) in Low & middle income and Employment to population ratio(%) in Italy?
Offer a terse response. 17.96. In the year 2005, what is the difference between the Employment to population ratio(%) in Fiji and Employment to population ratio(%) in Italy?
Provide a short and direct response. 13.7. In the year 2006, what is the difference between the Employment to population ratio(%) in Arab World and Employment to population ratio(%) in Low & middle income?
Your answer should be compact. -7.65. In the year 2006, what is the difference between the Employment to population ratio(%) in Arab World and Employment to population ratio(%) in Fiji?
Provide a short and direct response. -1.65. In the year 2006, what is the difference between the Employment to population ratio(%) in Arab World and Employment to population ratio(%) in Italy?
Your answer should be compact. 9.95. In the year 2006, what is the difference between the Employment to population ratio(%) in Low & middle income and Employment to population ratio(%) in Fiji?
Offer a very short reply. 6. In the year 2006, what is the difference between the Employment to population ratio(%) of Low & middle income and Employment to population ratio(%) of Italy?
Your answer should be very brief. 17.6. In the year 2006, what is the difference between the Employment to population ratio(%) of Fiji and Employment to population ratio(%) of Italy?
Your response must be concise. 11.6. What is the ratio of the Employment to population ratio(%) in Arab World in 1999 to that in 2000?
Make the answer very short. 1.01. What is the ratio of the Employment to population ratio(%) in Fiji in 1999 to that in 2000?
Ensure brevity in your answer.  1.01. What is the ratio of the Employment to population ratio(%) in Arab World in 1999 to that in 2001?
Ensure brevity in your answer.  1.02. What is the ratio of the Employment to population ratio(%) of Fiji in 1999 to that in 2001?
Keep it short and to the point. 1. What is the ratio of the Employment to population ratio(%) of Italy in 1999 to that in 2001?
Your response must be concise. 0.99. What is the ratio of the Employment to population ratio(%) in Arab World in 1999 to that in 2002?
Provide a short and direct response. 1.02. What is the ratio of the Employment to population ratio(%) of Low & middle income in 1999 to that in 2002?
Provide a short and direct response. 1.01. What is the ratio of the Employment to population ratio(%) in Italy in 1999 to that in 2002?
Keep it short and to the point. 0.98. What is the ratio of the Employment to population ratio(%) in Arab World in 1999 to that in 2003?
Provide a short and direct response. 1.02. What is the ratio of the Employment to population ratio(%) of Low & middle income in 1999 to that in 2003?
Your answer should be compact. 1.01. What is the ratio of the Employment to population ratio(%) of Fiji in 1999 to that in 2003?
Give a very brief answer. 1.03. What is the ratio of the Employment to population ratio(%) of Italy in 1999 to that in 2003?
Offer a terse response. 0.97. What is the ratio of the Employment to population ratio(%) in Arab World in 1999 to that in 2004?
Provide a succinct answer. 1.01. What is the ratio of the Employment to population ratio(%) of Low & middle income in 1999 to that in 2004?
Provide a short and direct response. 1.02. What is the ratio of the Employment to population ratio(%) of Italy in 1999 to that in 2004?
Keep it short and to the point. 0.97. What is the ratio of the Employment to population ratio(%) in Arab World in 1999 to that in 2005?
Offer a terse response. 0.99. What is the ratio of the Employment to population ratio(%) in Low & middle income in 1999 to that in 2005?
Offer a very short reply. 1.02. What is the ratio of the Employment to population ratio(%) of Italy in 1999 to that in 2005?
Provide a succinct answer. 0.97. What is the ratio of the Employment to population ratio(%) of Low & middle income in 1999 to that in 2006?
Keep it short and to the point. 1.02. What is the ratio of the Employment to population ratio(%) in Fiji in 1999 to that in 2006?
Ensure brevity in your answer.  1.03. What is the ratio of the Employment to population ratio(%) of Italy in 1999 to that in 2006?
Your response must be concise. 0.97. What is the ratio of the Employment to population ratio(%) of Arab World in 2000 to that in 2001?
Provide a succinct answer. 1. What is the ratio of the Employment to population ratio(%) in Low & middle income in 2000 to that in 2001?
Ensure brevity in your answer.  1. What is the ratio of the Employment to population ratio(%) of Fiji in 2000 to that in 2001?
Ensure brevity in your answer.  0.99. What is the ratio of the Employment to population ratio(%) in Italy in 2000 to that in 2001?
Your answer should be very brief. 0.99. What is the ratio of the Employment to population ratio(%) of Arab World in 2000 to that in 2002?
Provide a short and direct response. 1.01. What is the ratio of the Employment to population ratio(%) of Low & middle income in 2000 to that in 2002?
Offer a terse response. 1.01. What is the ratio of the Employment to population ratio(%) in Italy in 2000 to that in 2002?
Your response must be concise. 0.98. What is the ratio of the Employment to population ratio(%) in Arab World in 2000 to that in 2003?
Provide a short and direct response. 1.01. What is the ratio of the Employment to population ratio(%) of Low & middle income in 2000 to that in 2003?
Offer a terse response. 1.01. What is the ratio of the Employment to population ratio(%) of Fiji in 2000 to that in 2003?
Ensure brevity in your answer.  1.02. What is the ratio of the Employment to population ratio(%) in Italy in 2000 to that in 2003?
Your answer should be very brief. 0.98. What is the ratio of the Employment to population ratio(%) in Low & middle income in 2000 to that in 2004?
Provide a succinct answer. 1.01. What is the ratio of the Employment to population ratio(%) in Fiji in 2000 to that in 2004?
Offer a terse response. 0.99. What is the ratio of the Employment to population ratio(%) in Italy in 2000 to that in 2004?
Your response must be concise. 0.97. What is the ratio of the Employment to population ratio(%) in Arab World in 2000 to that in 2005?
Your answer should be compact. 0.98. What is the ratio of the Employment to population ratio(%) of Low & middle income in 2000 to that in 2005?
Your answer should be very brief. 1.01. What is the ratio of the Employment to population ratio(%) in Fiji in 2000 to that in 2005?
Keep it short and to the point. 1. What is the ratio of the Employment to population ratio(%) in Italy in 2000 to that in 2005?
Your answer should be compact. 0.98. What is the ratio of the Employment to population ratio(%) in Arab World in 2000 to that in 2006?
Keep it short and to the point. 0.98. What is the ratio of the Employment to population ratio(%) in Low & middle income in 2000 to that in 2006?
Your answer should be very brief. 1.01. What is the ratio of the Employment to population ratio(%) of Fiji in 2000 to that in 2006?
Give a very brief answer. 1.03. What is the ratio of the Employment to population ratio(%) of Low & middle income in 2001 to that in 2002?
Provide a succinct answer. 1.01. What is the ratio of the Employment to population ratio(%) of Italy in 2001 to that in 2002?
Your answer should be very brief. 0.99. What is the ratio of the Employment to population ratio(%) in Arab World in 2001 to that in 2003?
Ensure brevity in your answer.  1.01. What is the ratio of the Employment to population ratio(%) of Low & middle income in 2001 to that in 2003?
Keep it short and to the point. 1.01. What is the ratio of the Employment to population ratio(%) in Fiji in 2001 to that in 2003?
Ensure brevity in your answer.  1.03. What is the ratio of the Employment to population ratio(%) in Italy in 2001 to that in 2003?
Your answer should be compact. 0.98. What is the ratio of the Employment to population ratio(%) of Arab World in 2001 to that in 2004?
Offer a very short reply. 1. What is the ratio of the Employment to population ratio(%) of Low & middle income in 2001 to that in 2004?
Provide a short and direct response. 1.01. What is the ratio of the Employment to population ratio(%) in Fiji in 2001 to that in 2004?
Give a very brief answer. 1. What is the ratio of the Employment to population ratio(%) in Italy in 2001 to that in 2004?
Offer a terse response. 0.97. What is the ratio of the Employment to population ratio(%) of Arab World in 2001 to that in 2005?
Make the answer very short. 0.98. What is the ratio of the Employment to population ratio(%) of Fiji in 2001 to that in 2005?
Provide a succinct answer. 1.01. What is the ratio of the Employment to population ratio(%) in Italy in 2001 to that in 2005?
Offer a very short reply. 0.98. What is the ratio of the Employment to population ratio(%) in Arab World in 2001 to that in 2006?
Your answer should be very brief. 0.98. What is the ratio of the Employment to population ratio(%) of Low & middle income in 2001 to that in 2006?
Your answer should be very brief. 1.01. What is the ratio of the Employment to population ratio(%) in Fiji in 2001 to that in 2006?
Your answer should be compact. 1.04. What is the ratio of the Employment to population ratio(%) in Italy in 2001 to that in 2006?
Your answer should be very brief. 0.98. What is the ratio of the Employment to population ratio(%) of Fiji in 2002 to that in 2003?
Offer a very short reply. 1.03. What is the ratio of the Employment to population ratio(%) of Low & middle income in 2002 to that in 2004?
Make the answer very short. 1. What is the ratio of the Employment to population ratio(%) of Italy in 2002 to that in 2004?
Your answer should be very brief. 0.98. What is the ratio of the Employment to population ratio(%) of Arab World in 2002 to that in 2005?
Make the answer very short. 0.98. What is the ratio of the Employment to population ratio(%) in Low & middle income in 2002 to that in 2005?
Ensure brevity in your answer.  1. What is the ratio of the Employment to population ratio(%) in Fiji in 2002 to that in 2005?
Give a very brief answer. 1.01. What is the ratio of the Employment to population ratio(%) of Arab World in 2002 to that in 2006?
Provide a short and direct response. 0.98. What is the ratio of the Employment to population ratio(%) of Low & middle income in 2002 to that in 2006?
Keep it short and to the point. 1.01. What is the ratio of the Employment to population ratio(%) in Fiji in 2002 to that in 2006?
Offer a terse response. 1.03. What is the ratio of the Employment to population ratio(%) in Low & middle income in 2003 to that in 2004?
Your answer should be compact. 1. What is the ratio of the Employment to population ratio(%) in Fiji in 2003 to that in 2004?
Offer a terse response. 0.97. What is the ratio of the Employment to population ratio(%) in Arab World in 2003 to that in 2005?
Offer a very short reply. 0.97. What is the ratio of the Employment to population ratio(%) of Low & middle income in 2003 to that in 2005?
Your response must be concise. 1. What is the ratio of the Employment to population ratio(%) in Fiji in 2003 to that in 2005?
Offer a very short reply. 0.98. What is the ratio of the Employment to population ratio(%) in Italy in 2003 to that in 2005?
Your response must be concise. 1. What is the ratio of the Employment to population ratio(%) in Arab World in 2003 to that in 2006?
Your answer should be very brief. 0.97. What is the ratio of the Employment to population ratio(%) of Low & middle income in 2003 to that in 2006?
Your response must be concise. 1. What is the ratio of the Employment to population ratio(%) in Fiji in 2003 to that in 2006?
Ensure brevity in your answer.  1.01. What is the ratio of the Employment to population ratio(%) in Arab World in 2004 to that in 2005?
Your answer should be very brief. 0.98. What is the ratio of the Employment to population ratio(%) of Low & middle income in 2004 to that in 2005?
Provide a short and direct response. 1. What is the ratio of the Employment to population ratio(%) in Italy in 2004 to that in 2005?
Your answer should be compact. 1.01. What is the ratio of the Employment to population ratio(%) in Arab World in 2004 to that in 2006?
Provide a succinct answer. 0.98. What is the ratio of the Employment to population ratio(%) in Low & middle income in 2004 to that in 2006?
Your answer should be compact. 1. What is the ratio of the Employment to population ratio(%) of Fiji in 2004 to that in 2006?
Your response must be concise. 1.03. What is the ratio of the Employment to population ratio(%) in Italy in 2004 to that in 2006?
Offer a terse response. 1.01. What is the ratio of the Employment to population ratio(%) of Arab World in 2005 to that in 2006?
Offer a very short reply. 1. What is the ratio of the Employment to population ratio(%) in Fiji in 2005 to that in 2006?
Keep it short and to the point. 1.03. What is the ratio of the Employment to population ratio(%) in Italy in 2005 to that in 2006?
Provide a succinct answer. 1. What is the difference between the highest and the second highest Employment to population ratio(%) of Arab World?
Keep it short and to the point. 0.09. What is the difference between the highest and the second highest Employment to population ratio(%) of Low & middle income?
Make the answer very short. 0.34. What is the difference between the highest and the lowest Employment to population ratio(%) in Arab World?
Offer a very short reply. 1.86. What is the difference between the highest and the lowest Employment to population ratio(%) in Low & middle income?
Give a very brief answer. 1.47. 